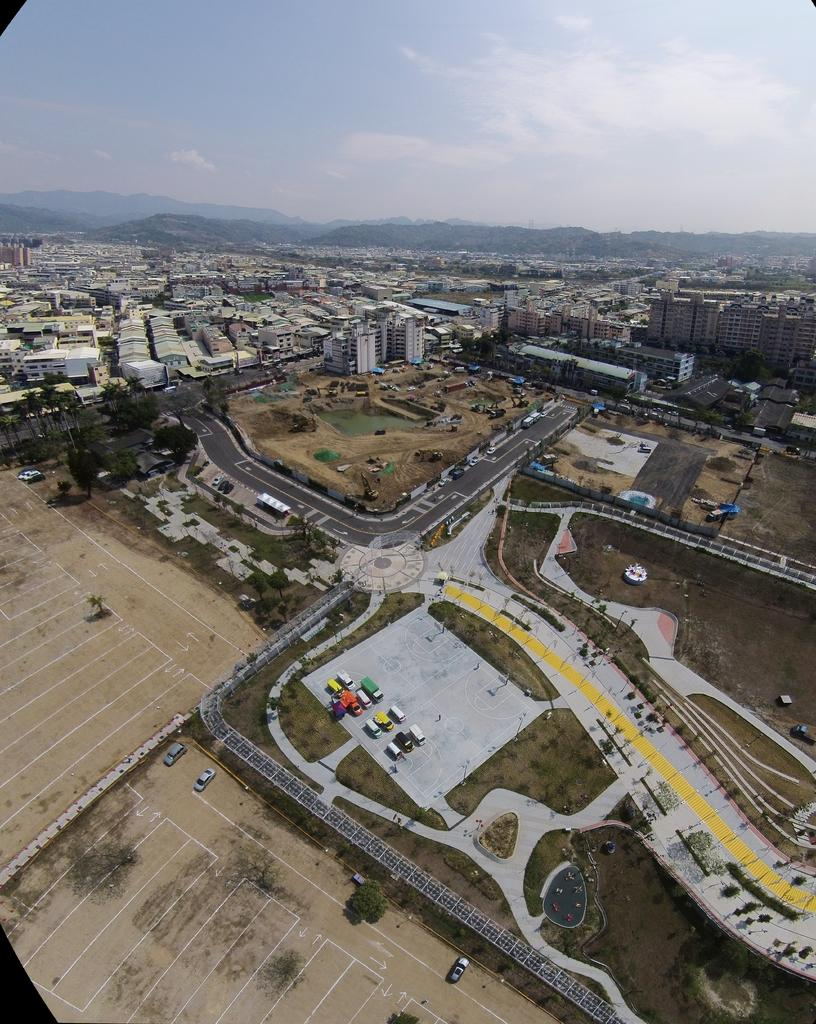What type of structures can be seen in the image? There are buildings in the image. What else can be seen moving in the image? There are vehicles in the image. What type of natural elements are present in the image? There are trees and hills in the image. What is visible at the top of the image? Clouds and the sky are visible at the top of the image. Can you tell me how many engines are visible in the image? There is no engine present in the image. What type of approval is required to access the seashoreashore in the image? There is no seashore present in the image; it features buildings, vehicles, trees, hills, clouds, and the sky. 